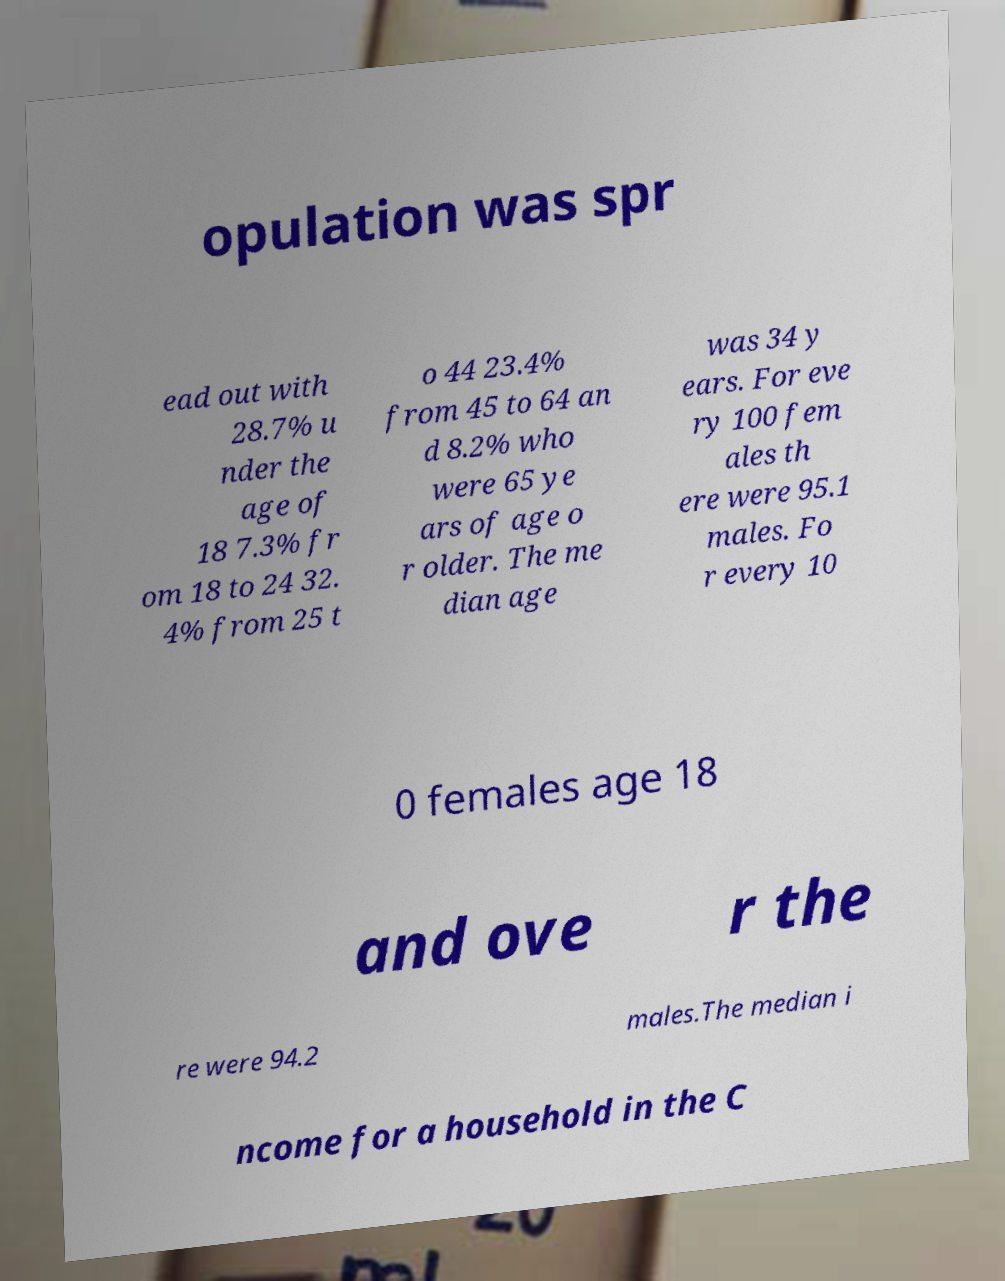Could you assist in decoding the text presented in this image and type it out clearly? opulation was spr ead out with 28.7% u nder the age of 18 7.3% fr om 18 to 24 32. 4% from 25 t o 44 23.4% from 45 to 64 an d 8.2% who were 65 ye ars of age o r older. The me dian age was 34 y ears. For eve ry 100 fem ales th ere were 95.1 males. Fo r every 10 0 females age 18 and ove r the re were 94.2 males.The median i ncome for a household in the C 